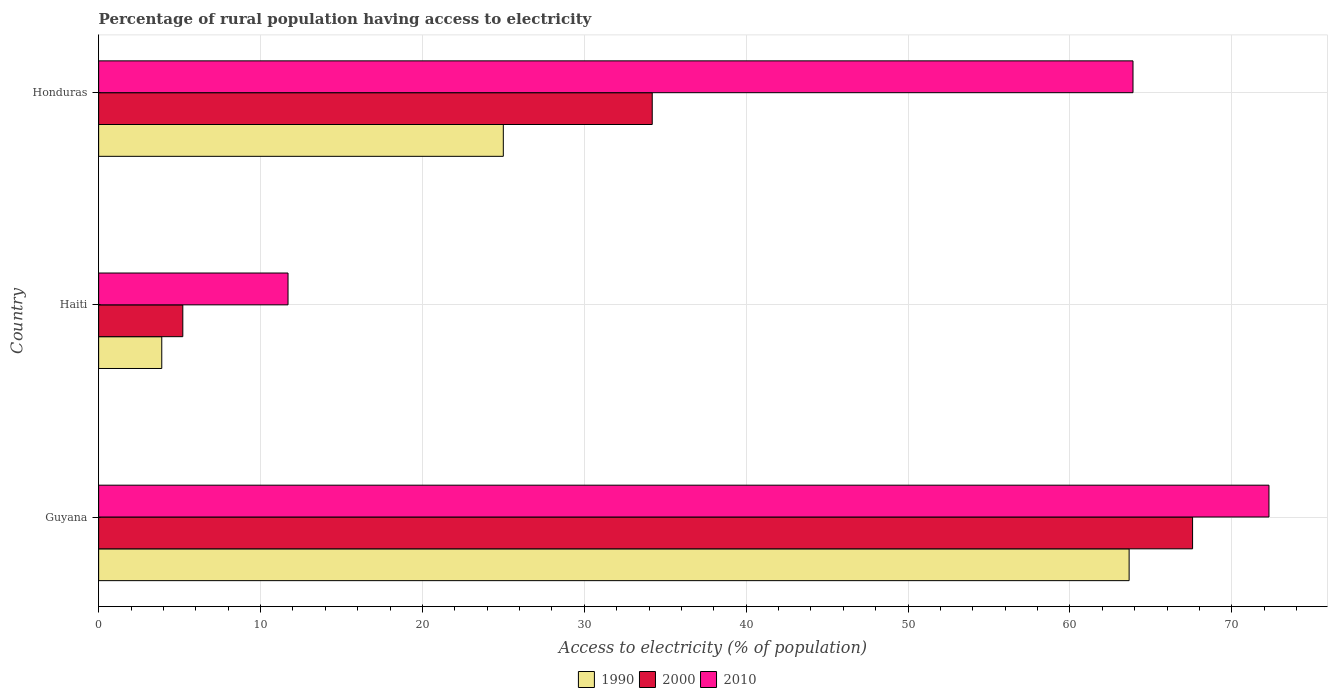How many different coloured bars are there?
Ensure brevity in your answer.  3. How many bars are there on the 1st tick from the top?
Provide a short and direct response. 3. How many bars are there on the 2nd tick from the bottom?
Keep it short and to the point. 3. What is the label of the 2nd group of bars from the top?
Make the answer very short. Haiti. Across all countries, what is the maximum percentage of rural population having access to electricity in 2000?
Your answer should be very brief. 67.58. Across all countries, what is the minimum percentage of rural population having access to electricity in 2010?
Make the answer very short. 11.7. In which country was the percentage of rural population having access to electricity in 2010 maximum?
Offer a very short reply. Guyana. In which country was the percentage of rural population having access to electricity in 1990 minimum?
Offer a very short reply. Haiti. What is the total percentage of rural population having access to electricity in 2010 in the graph?
Give a very brief answer. 147.9. What is the difference between the percentage of rural population having access to electricity in 2000 in Guyana and that in Honduras?
Your response must be concise. 33.38. What is the difference between the percentage of rural population having access to electricity in 1990 in Guyana and the percentage of rural population having access to electricity in 2000 in Haiti?
Keep it short and to the point. 58.46. What is the average percentage of rural population having access to electricity in 2010 per country?
Offer a very short reply. 49.3. What is the difference between the percentage of rural population having access to electricity in 2010 and percentage of rural population having access to electricity in 1990 in Haiti?
Keep it short and to the point. 7.8. In how many countries, is the percentage of rural population having access to electricity in 1990 greater than 44 %?
Your answer should be very brief. 1. What is the ratio of the percentage of rural population having access to electricity in 2010 in Haiti to that in Honduras?
Offer a terse response. 0.18. Is the percentage of rural population having access to electricity in 1990 in Guyana less than that in Honduras?
Offer a terse response. No. What is the difference between the highest and the second highest percentage of rural population having access to electricity in 1990?
Your answer should be very brief. 38.66. What is the difference between the highest and the lowest percentage of rural population having access to electricity in 2010?
Your answer should be compact. 60.6. In how many countries, is the percentage of rural population having access to electricity in 2000 greater than the average percentage of rural population having access to electricity in 2000 taken over all countries?
Your response must be concise. 1. Is the sum of the percentage of rural population having access to electricity in 2010 in Haiti and Honduras greater than the maximum percentage of rural population having access to electricity in 2000 across all countries?
Your answer should be compact. Yes. Is it the case that in every country, the sum of the percentage of rural population having access to electricity in 1990 and percentage of rural population having access to electricity in 2010 is greater than the percentage of rural population having access to electricity in 2000?
Give a very brief answer. Yes. How many bars are there?
Your response must be concise. 9. Are all the bars in the graph horizontal?
Offer a very short reply. Yes. Does the graph contain any zero values?
Ensure brevity in your answer.  No. Does the graph contain grids?
Ensure brevity in your answer.  Yes. How many legend labels are there?
Offer a terse response. 3. How are the legend labels stacked?
Your answer should be very brief. Horizontal. What is the title of the graph?
Make the answer very short. Percentage of rural population having access to electricity. What is the label or title of the X-axis?
Your answer should be compact. Access to electricity (% of population). What is the Access to electricity (% of population) of 1990 in Guyana?
Your answer should be compact. 63.66. What is the Access to electricity (% of population) in 2000 in Guyana?
Provide a short and direct response. 67.58. What is the Access to electricity (% of population) in 2010 in Guyana?
Offer a terse response. 72.3. What is the Access to electricity (% of population) in 1990 in Haiti?
Your answer should be compact. 3.9. What is the Access to electricity (% of population) of 1990 in Honduras?
Your answer should be very brief. 25. What is the Access to electricity (% of population) in 2000 in Honduras?
Offer a very short reply. 34.2. What is the Access to electricity (% of population) of 2010 in Honduras?
Provide a succinct answer. 63.9. Across all countries, what is the maximum Access to electricity (% of population) in 1990?
Provide a succinct answer. 63.66. Across all countries, what is the maximum Access to electricity (% of population) in 2000?
Give a very brief answer. 67.58. Across all countries, what is the maximum Access to electricity (% of population) in 2010?
Ensure brevity in your answer.  72.3. Across all countries, what is the minimum Access to electricity (% of population) of 1990?
Ensure brevity in your answer.  3.9. Across all countries, what is the minimum Access to electricity (% of population) of 2010?
Ensure brevity in your answer.  11.7. What is the total Access to electricity (% of population) in 1990 in the graph?
Your answer should be very brief. 92.56. What is the total Access to electricity (% of population) of 2000 in the graph?
Ensure brevity in your answer.  106.98. What is the total Access to electricity (% of population) in 2010 in the graph?
Your answer should be compact. 147.9. What is the difference between the Access to electricity (% of population) of 1990 in Guyana and that in Haiti?
Give a very brief answer. 59.76. What is the difference between the Access to electricity (% of population) in 2000 in Guyana and that in Haiti?
Make the answer very short. 62.38. What is the difference between the Access to electricity (% of population) in 2010 in Guyana and that in Haiti?
Offer a terse response. 60.6. What is the difference between the Access to electricity (% of population) of 1990 in Guyana and that in Honduras?
Your answer should be very brief. 38.66. What is the difference between the Access to electricity (% of population) of 2000 in Guyana and that in Honduras?
Your answer should be compact. 33.38. What is the difference between the Access to electricity (% of population) of 1990 in Haiti and that in Honduras?
Keep it short and to the point. -21.1. What is the difference between the Access to electricity (% of population) in 2000 in Haiti and that in Honduras?
Offer a terse response. -29. What is the difference between the Access to electricity (% of population) of 2010 in Haiti and that in Honduras?
Make the answer very short. -52.2. What is the difference between the Access to electricity (% of population) in 1990 in Guyana and the Access to electricity (% of population) in 2000 in Haiti?
Make the answer very short. 58.46. What is the difference between the Access to electricity (% of population) in 1990 in Guyana and the Access to electricity (% of population) in 2010 in Haiti?
Keep it short and to the point. 51.96. What is the difference between the Access to electricity (% of population) in 2000 in Guyana and the Access to electricity (% of population) in 2010 in Haiti?
Ensure brevity in your answer.  55.88. What is the difference between the Access to electricity (% of population) of 1990 in Guyana and the Access to electricity (% of population) of 2000 in Honduras?
Offer a very short reply. 29.46. What is the difference between the Access to electricity (% of population) in 1990 in Guyana and the Access to electricity (% of population) in 2010 in Honduras?
Offer a very short reply. -0.24. What is the difference between the Access to electricity (% of population) of 2000 in Guyana and the Access to electricity (% of population) of 2010 in Honduras?
Your answer should be very brief. 3.68. What is the difference between the Access to electricity (% of population) in 1990 in Haiti and the Access to electricity (% of population) in 2000 in Honduras?
Ensure brevity in your answer.  -30.3. What is the difference between the Access to electricity (% of population) of 1990 in Haiti and the Access to electricity (% of population) of 2010 in Honduras?
Keep it short and to the point. -60. What is the difference between the Access to electricity (% of population) in 2000 in Haiti and the Access to electricity (% of population) in 2010 in Honduras?
Your answer should be compact. -58.7. What is the average Access to electricity (% of population) of 1990 per country?
Ensure brevity in your answer.  30.85. What is the average Access to electricity (% of population) of 2000 per country?
Your answer should be very brief. 35.66. What is the average Access to electricity (% of population) in 2010 per country?
Offer a very short reply. 49.3. What is the difference between the Access to electricity (% of population) in 1990 and Access to electricity (% of population) in 2000 in Guyana?
Your answer should be compact. -3.92. What is the difference between the Access to electricity (% of population) of 1990 and Access to electricity (% of population) of 2010 in Guyana?
Your answer should be very brief. -8.64. What is the difference between the Access to electricity (% of population) of 2000 and Access to electricity (% of population) of 2010 in Guyana?
Provide a short and direct response. -4.72. What is the difference between the Access to electricity (% of population) of 1990 and Access to electricity (% of population) of 2010 in Haiti?
Provide a succinct answer. -7.8. What is the difference between the Access to electricity (% of population) in 2000 and Access to electricity (% of population) in 2010 in Haiti?
Your response must be concise. -6.5. What is the difference between the Access to electricity (% of population) in 1990 and Access to electricity (% of population) in 2010 in Honduras?
Your answer should be compact. -38.9. What is the difference between the Access to electricity (% of population) of 2000 and Access to electricity (% of population) of 2010 in Honduras?
Your answer should be compact. -29.7. What is the ratio of the Access to electricity (% of population) of 1990 in Guyana to that in Haiti?
Your response must be concise. 16.32. What is the ratio of the Access to electricity (% of population) in 2000 in Guyana to that in Haiti?
Ensure brevity in your answer.  13. What is the ratio of the Access to electricity (% of population) of 2010 in Guyana to that in Haiti?
Provide a short and direct response. 6.18. What is the ratio of the Access to electricity (% of population) of 1990 in Guyana to that in Honduras?
Give a very brief answer. 2.55. What is the ratio of the Access to electricity (% of population) of 2000 in Guyana to that in Honduras?
Keep it short and to the point. 1.98. What is the ratio of the Access to electricity (% of population) in 2010 in Guyana to that in Honduras?
Offer a terse response. 1.13. What is the ratio of the Access to electricity (% of population) in 1990 in Haiti to that in Honduras?
Your response must be concise. 0.16. What is the ratio of the Access to electricity (% of population) in 2000 in Haiti to that in Honduras?
Your answer should be very brief. 0.15. What is the ratio of the Access to electricity (% of population) in 2010 in Haiti to that in Honduras?
Give a very brief answer. 0.18. What is the difference between the highest and the second highest Access to electricity (% of population) in 1990?
Your answer should be very brief. 38.66. What is the difference between the highest and the second highest Access to electricity (% of population) in 2000?
Your answer should be compact. 33.38. What is the difference between the highest and the lowest Access to electricity (% of population) in 1990?
Your answer should be compact. 59.76. What is the difference between the highest and the lowest Access to electricity (% of population) of 2000?
Make the answer very short. 62.38. What is the difference between the highest and the lowest Access to electricity (% of population) in 2010?
Provide a short and direct response. 60.6. 